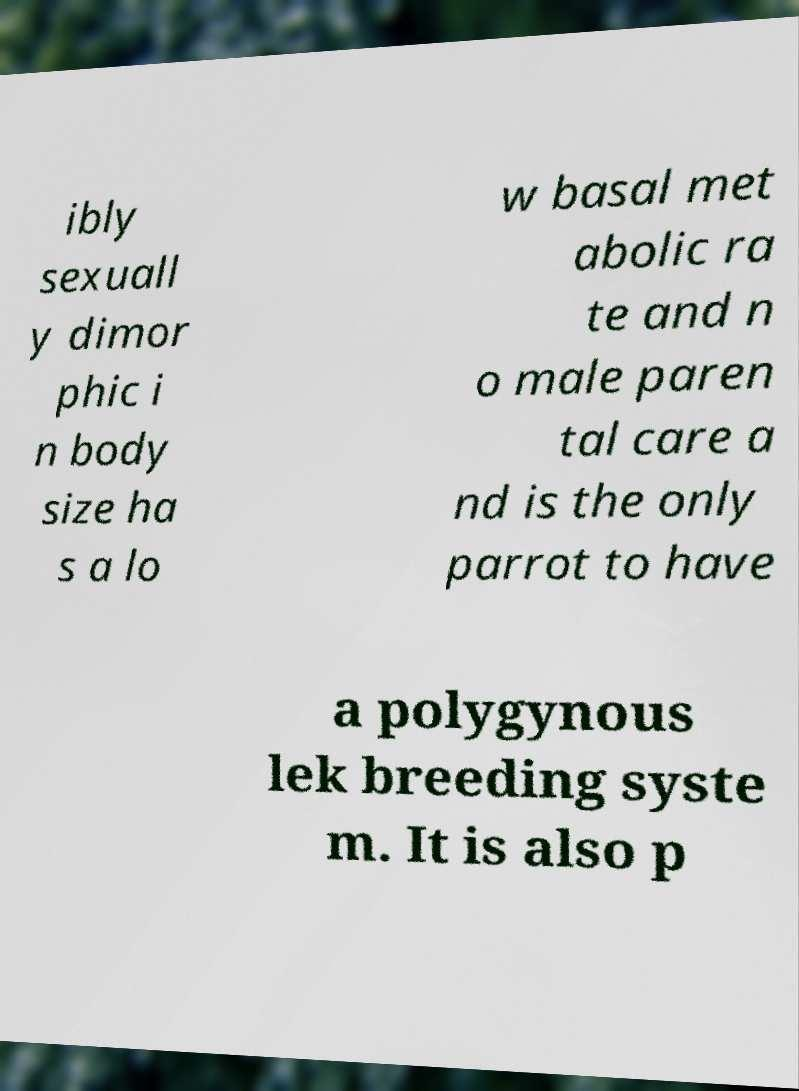Please read and relay the text visible in this image. What does it say? ibly sexuall y dimor phic i n body size ha s a lo w basal met abolic ra te and n o male paren tal care a nd is the only parrot to have a polygynous lek breeding syste m. It is also p 